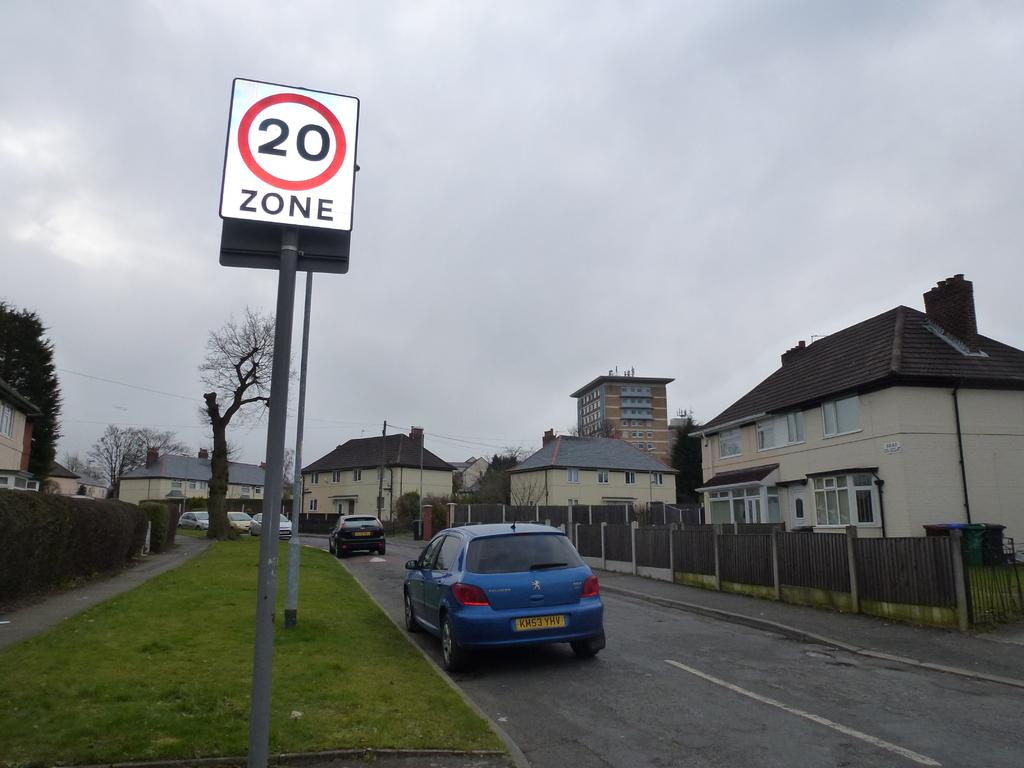<image>
Share a concise interpretation of the image provided. Blue car parked in front of a sign which says 20 Zone. 